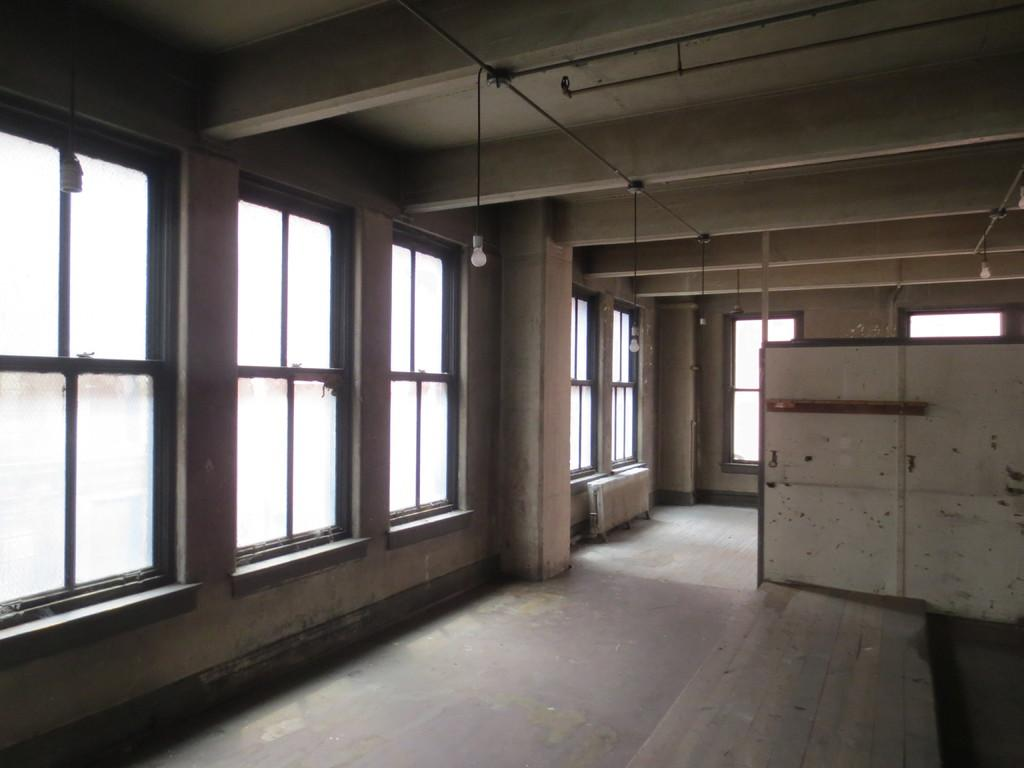Where was the image taken? The image was taken inside a room. What type of windows are present in the room? There are glass windows in the room. How are the windows attached to the room? The windows are attached to the wall. What is above the room? There is a ceiling in the room. What can be seen hanging from the ceiling? Lights are hanging from the ceiling. What type of bag can be seen on the sidewalk outside the room in the image? There is no bag or sidewalk present in the image; it was taken inside a room with glass windows, a ceiling, and lights hanging from it. 